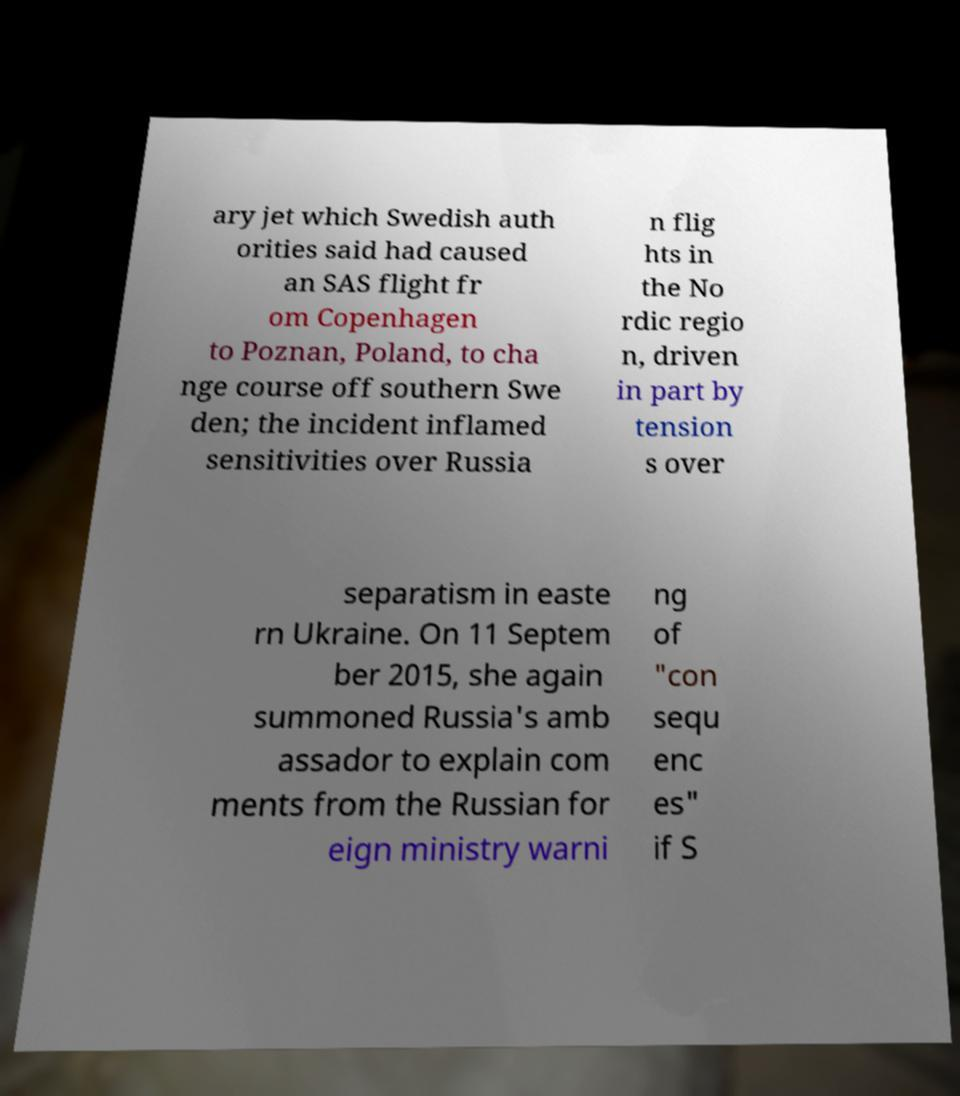Please read and relay the text visible in this image. What does it say? ary jet which Swedish auth orities said had caused an SAS flight fr om Copenhagen to Poznan, Poland, to cha nge course off southern Swe den; the incident inflamed sensitivities over Russia n flig hts in the No rdic regio n, driven in part by tension s over separatism in easte rn Ukraine. On 11 Septem ber 2015, she again summoned Russia's amb assador to explain com ments from the Russian for eign ministry warni ng of "con sequ enc es" if S 